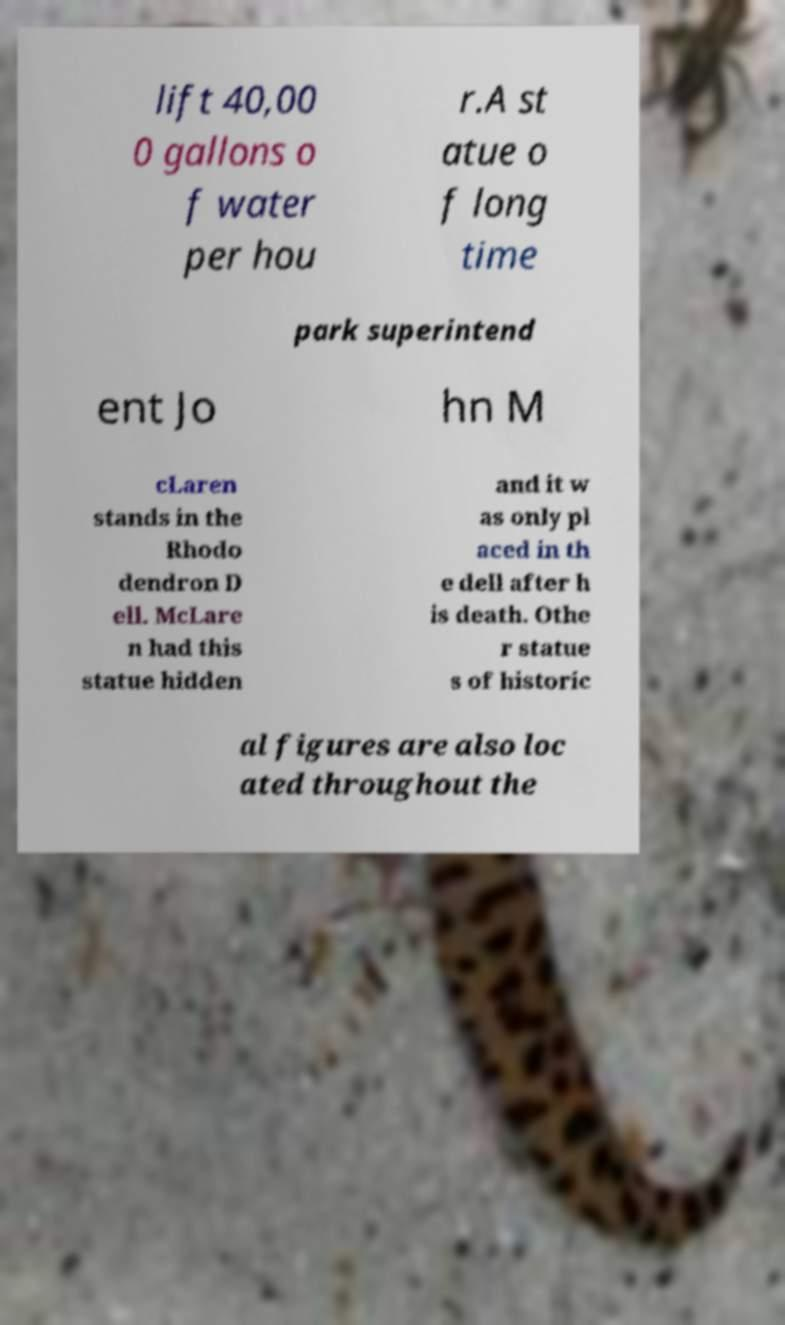Can you read and provide the text displayed in the image?This photo seems to have some interesting text. Can you extract and type it out for me? lift 40,00 0 gallons o f water per hou r.A st atue o f long time park superintend ent Jo hn M cLaren stands in the Rhodo dendron D ell. McLare n had this statue hidden and it w as only pl aced in th e dell after h is death. Othe r statue s of historic al figures are also loc ated throughout the 